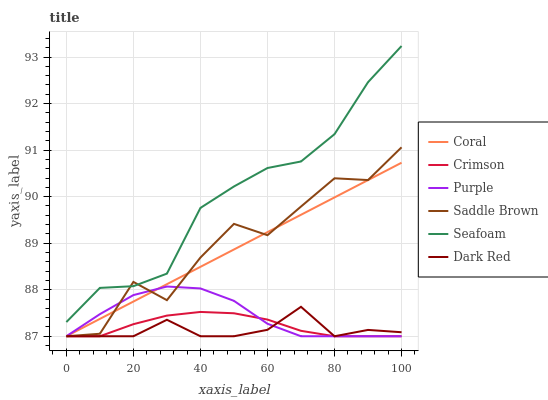Does Coral have the minimum area under the curve?
Answer yes or no. No. Does Coral have the maximum area under the curve?
Answer yes or no. No. Is Dark Red the smoothest?
Answer yes or no. No. Is Dark Red the roughest?
Answer yes or no. No. Does Seafoam have the lowest value?
Answer yes or no. No. Does Dark Red have the highest value?
Answer yes or no. No. Is Coral less than Seafoam?
Answer yes or no. Yes. Is Seafoam greater than Coral?
Answer yes or no. Yes. Does Coral intersect Seafoam?
Answer yes or no. No. 